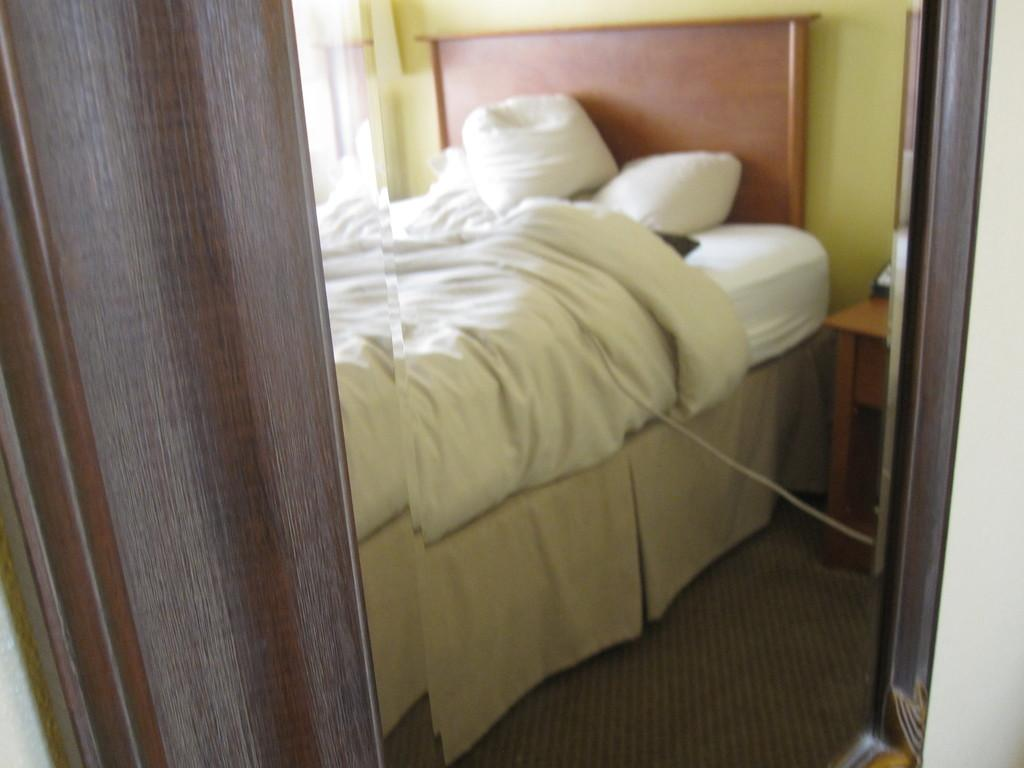What type of room is depicted in the image? The room is a bedroom. What color are the bed sheets in the image? The bed sheet is white-colored. What other white-colored items can be seen in the image? There are white-colored pillows and a white-colored mattress. What color is the wall in the background of the image? The wall in the background is yellow-colored. How many sisters are sitting on the white-colored mattress in the image? There are no sisters present in the image; it only shows a bedroom with a white-colored mattress. Can you see any grass in the image? There is no grass visible in the image, as it is an indoor scene featuring a bedroom. 